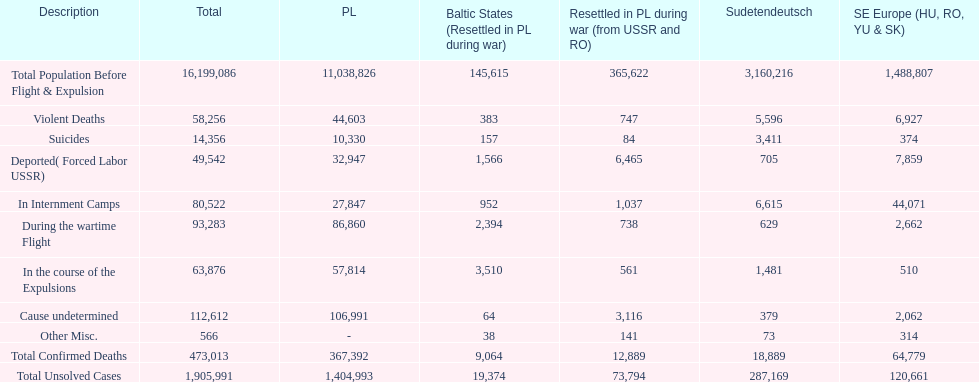What is the total number of violent deaths across all regions? 58,256. 